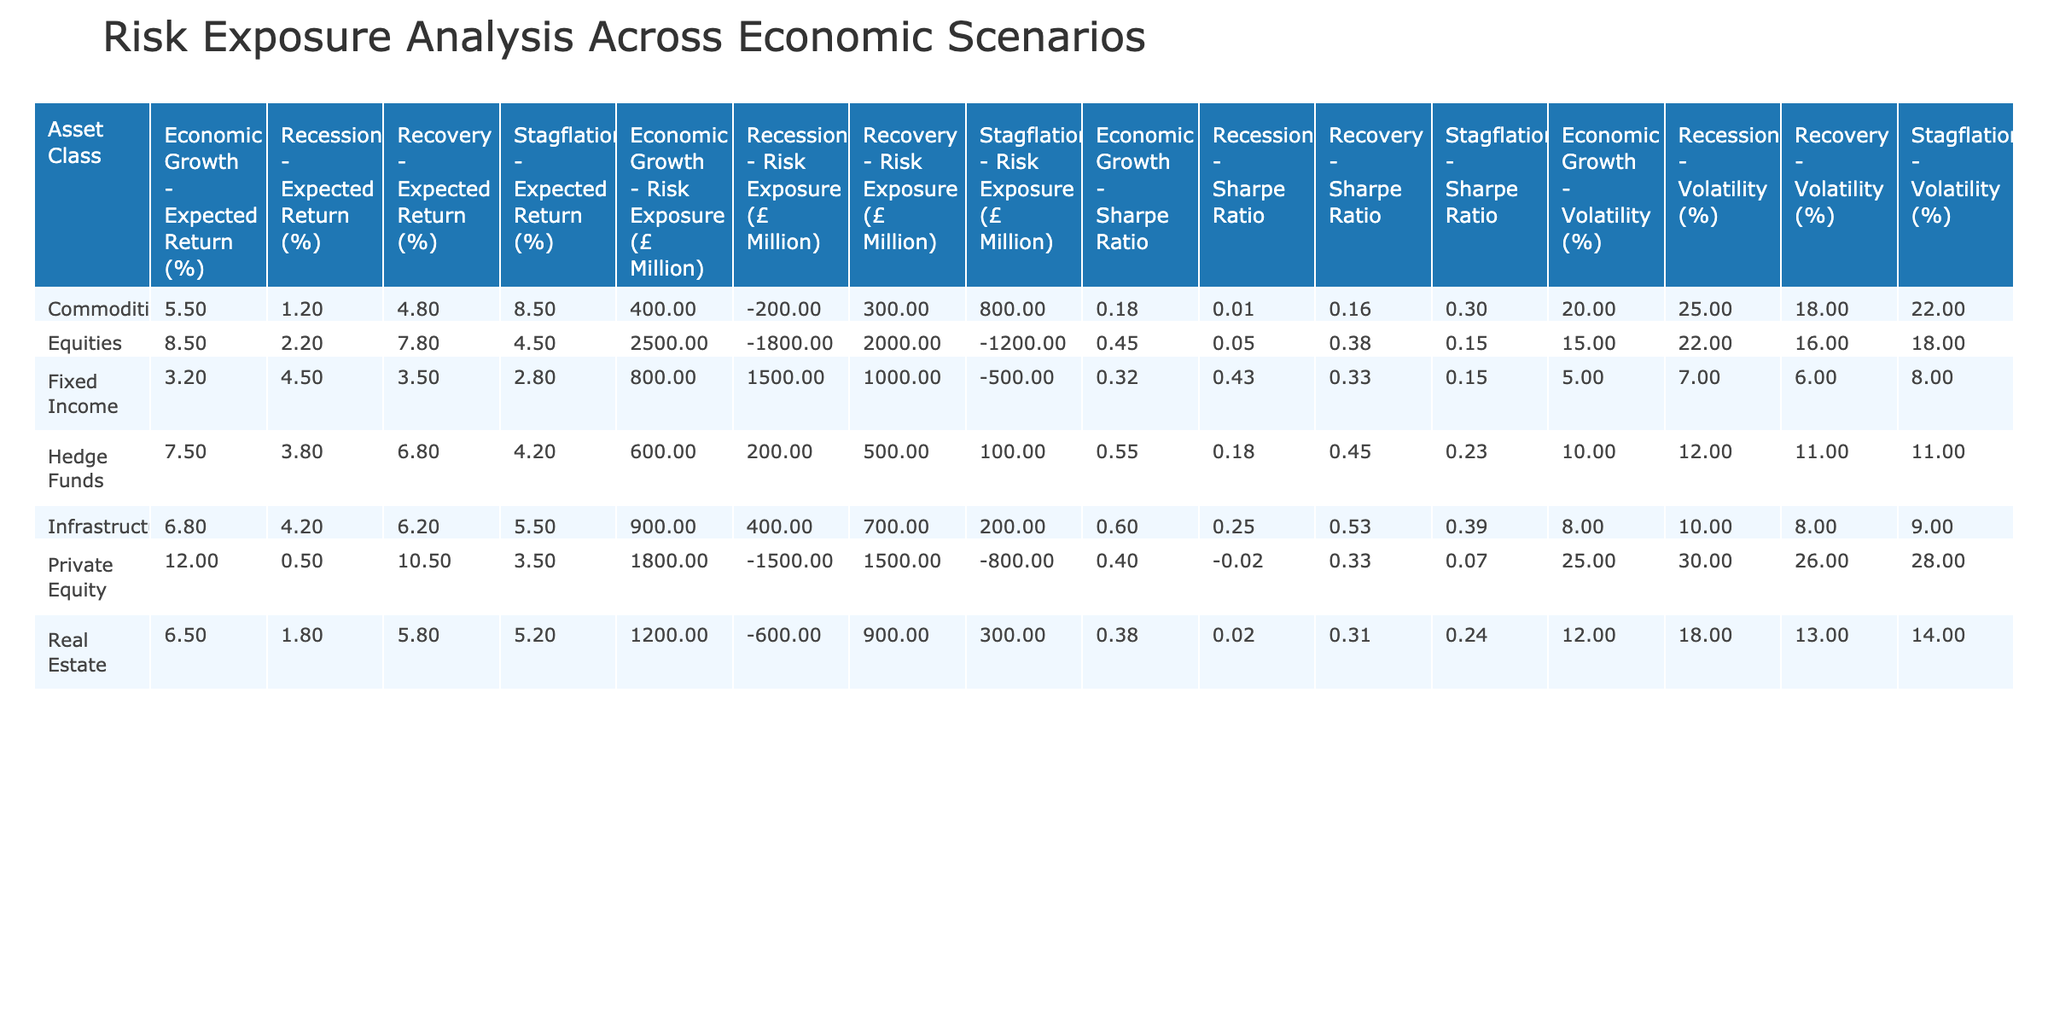What is the risk exposure for Private Equity during a recession? The table shows that the risk exposure for Private Equity under the recession scenario is -1500.
Answer: -1500 What is the expected return of Fixed Income during economic growth? By checking the Fixed Income row under the economic growth column, the expected return is 3.2%.
Answer: 3.2% Which asset class has the highest expected return during the recovery scenario? When looking at the recovery column, Private Equity shows the highest expected return of 10.5%.
Answer: Private Equity What is the average risk exposure across all asset classes during stagflation? The risk exposures during stagflation for each asset class are: -1200 (Equities), -500 (Fixed Income), 300 (Real Estate), 800 (Commodities), -800 (Private Equity), 100 (Hedge Funds), and 200 (Infrastructure). Summing these gives -2100, and dividing by 7 asset classes results in an average of -300.
Answer: -300 Is the Sharpe Ratio for Real Estate during recession greater than 0? The Sharpe Ratio for Real Estate during the recession is 0.02, which is greater than 0.
Answer: Yes What is the total risk exposure for Equities when combining the results from all scenarios? To find the total risk exposure for Equities, we add the values from each scenario: 2500 (Economic Growth) + (-1800) (Recession) + (-1200) (Stagflation) + 2000 (Recovery). This results in a total risk exposure of 2500 - 1800 - 1200 + 2000 = 1500.
Answer: 1500 Which asset class experiences the least volatility during the economic growth scenario? In the economic growth scenario, the table indicates that Fixed Income has the lowest volatility at 5%.
Answer: Fixed Income What is the difference in Sharpe Ratios between Commodities and Hedge Funds during stagflation? The Sharpe Ratio for Commodities during stagflation is 0.3 and for Hedge Funds, it is 0.23. The difference is 0.3 - 0.23 = 0.07.
Answer: 0.07 Does Infrastructure have a higher expected return during the recovery compared to Equities? The expected return for Infrastructure during recovery is 6.2% while for Equities, it is 7.8%. Since 6.2% is less than 7.8%, the statement is false.
Answer: No 